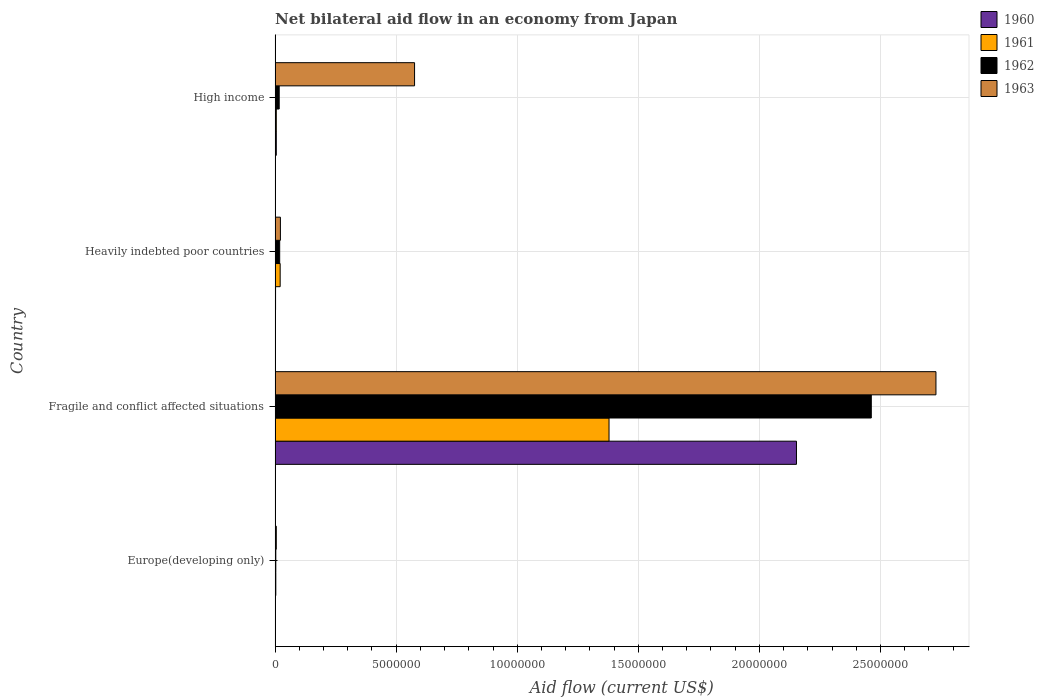How many groups of bars are there?
Keep it short and to the point. 4. Are the number of bars on each tick of the Y-axis equal?
Your answer should be compact. Yes. How many bars are there on the 4th tick from the top?
Offer a very short reply. 4. What is the label of the 3rd group of bars from the top?
Keep it short and to the point. Fragile and conflict affected situations. In how many cases, is the number of bars for a given country not equal to the number of legend labels?
Give a very brief answer. 0. What is the net bilateral aid flow in 1962 in Heavily indebted poor countries?
Give a very brief answer. 1.90e+05. Across all countries, what is the maximum net bilateral aid flow in 1962?
Make the answer very short. 2.46e+07. In which country was the net bilateral aid flow in 1961 maximum?
Give a very brief answer. Fragile and conflict affected situations. In which country was the net bilateral aid flow in 1963 minimum?
Your answer should be compact. Europe(developing only). What is the total net bilateral aid flow in 1961 in the graph?
Keep it short and to the point. 1.41e+07. What is the average net bilateral aid flow in 1962 per country?
Your answer should be very brief. 6.25e+06. What is the difference between the net bilateral aid flow in 1963 and net bilateral aid flow in 1960 in Heavily indebted poor countries?
Give a very brief answer. 2.00e+05. What is the ratio of the net bilateral aid flow in 1961 in Heavily indebted poor countries to that in High income?
Your answer should be very brief. 4.2. What is the difference between the highest and the second highest net bilateral aid flow in 1960?
Your answer should be compact. 2.15e+07. What is the difference between the highest and the lowest net bilateral aid flow in 1963?
Keep it short and to the point. 2.72e+07. In how many countries, is the net bilateral aid flow in 1960 greater than the average net bilateral aid flow in 1960 taken over all countries?
Your response must be concise. 1. Is it the case that in every country, the sum of the net bilateral aid flow in 1962 and net bilateral aid flow in 1963 is greater than the sum of net bilateral aid flow in 1960 and net bilateral aid flow in 1961?
Make the answer very short. Yes. What does the 2nd bar from the bottom in Europe(developing only) represents?
Your answer should be compact. 1961. Are all the bars in the graph horizontal?
Ensure brevity in your answer.  Yes. What is the difference between two consecutive major ticks on the X-axis?
Make the answer very short. 5.00e+06. Are the values on the major ticks of X-axis written in scientific E-notation?
Your answer should be compact. No. Does the graph contain grids?
Keep it short and to the point. Yes. How many legend labels are there?
Give a very brief answer. 4. What is the title of the graph?
Make the answer very short. Net bilateral aid flow in an economy from Japan. What is the Aid flow (current US$) of 1963 in Europe(developing only)?
Give a very brief answer. 5.00e+04. What is the Aid flow (current US$) in 1960 in Fragile and conflict affected situations?
Offer a terse response. 2.15e+07. What is the Aid flow (current US$) in 1961 in Fragile and conflict affected situations?
Offer a very short reply. 1.38e+07. What is the Aid flow (current US$) in 1962 in Fragile and conflict affected situations?
Make the answer very short. 2.46e+07. What is the Aid flow (current US$) of 1963 in Fragile and conflict affected situations?
Provide a succinct answer. 2.73e+07. What is the Aid flow (current US$) of 1961 in Heavily indebted poor countries?
Make the answer very short. 2.10e+05. What is the Aid flow (current US$) of 1961 in High income?
Provide a short and direct response. 5.00e+04. What is the Aid flow (current US$) in 1963 in High income?
Keep it short and to the point. 5.76e+06. Across all countries, what is the maximum Aid flow (current US$) in 1960?
Give a very brief answer. 2.15e+07. Across all countries, what is the maximum Aid flow (current US$) of 1961?
Your answer should be very brief. 1.38e+07. Across all countries, what is the maximum Aid flow (current US$) in 1962?
Provide a short and direct response. 2.46e+07. Across all countries, what is the maximum Aid flow (current US$) of 1963?
Keep it short and to the point. 2.73e+07. Across all countries, what is the minimum Aid flow (current US$) in 1961?
Provide a short and direct response. 3.00e+04. Across all countries, what is the minimum Aid flow (current US$) of 1962?
Make the answer very short. 3.00e+04. What is the total Aid flow (current US$) in 1960 in the graph?
Your answer should be very brief. 2.16e+07. What is the total Aid flow (current US$) in 1961 in the graph?
Offer a very short reply. 1.41e+07. What is the total Aid flow (current US$) in 1962 in the graph?
Ensure brevity in your answer.  2.50e+07. What is the total Aid flow (current US$) of 1963 in the graph?
Offer a very short reply. 3.33e+07. What is the difference between the Aid flow (current US$) in 1960 in Europe(developing only) and that in Fragile and conflict affected situations?
Ensure brevity in your answer.  -2.15e+07. What is the difference between the Aid flow (current US$) of 1961 in Europe(developing only) and that in Fragile and conflict affected situations?
Ensure brevity in your answer.  -1.38e+07. What is the difference between the Aid flow (current US$) in 1962 in Europe(developing only) and that in Fragile and conflict affected situations?
Your answer should be very brief. -2.46e+07. What is the difference between the Aid flow (current US$) in 1963 in Europe(developing only) and that in Fragile and conflict affected situations?
Offer a very short reply. -2.72e+07. What is the difference between the Aid flow (current US$) of 1960 in Europe(developing only) and that in Heavily indebted poor countries?
Provide a short and direct response. -10000. What is the difference between the Aid flow (current US$) in 1962 in Europe(developing only) and that in Heavily indebted poor countries?
Provide a short and direct response. -1.60e+05. What is the difference between the Aid flow (current US$) in 1960 in Europe(developing only) and that in High income?
Offer a terse response. -4.00e+04. What is the difference between the Aid flow (current US$) of 1961 in Europe(developing only) and that in High income?
Ensure brevity in your answer.  -2.00e+04. What is the difference between the Aid flow (current US$) in 1962 in Europe(developing only) and that in High income?
Keep it short and to the point. -1.40e+05. What is the difference between the Aid flow (current US$) of 1963 in Europe(developing only) and that in High income?
Provide a short and direct response. -5.71e+06. What is the difference between the Aid flow (current US$) of 1960 in Fragile and conflict affected situations and that in Heavily indebted poor countries?
Your response must be concise. 2.15e+07. What is the difference between the Aid flow (current US$) in 1961 in Fragile and conflict affected situations and that in Heavily indebted poor countries?
Offer a very short reply. 1.36e+07. What is the difference between the Aid flow (current US$) of 1962 in Fragile and conflict affected situations and that in Heavily indebted poor countries?
Offer a very short reply. 2.44e+07. What is the difference between the Aid flow (current US$) of 1963 in Fragile and conflict affected situations and that in Heavily indebted poor countries?
Offer a terse response. 2.71e+07. What is the difference between the Aid flow (current US$) in 1960 in Fragile and conflict affected situations and that in High income?
Your response must be concise. 2.15e+07. What is the difference between the Aid flow (current US$) in 1961 in Fragile and conflict affected situations and that in High income?
Provide a succinct answer. 1.37e+07. What is the difference between the Aid flow (current US$) in 1962 in Fragile and conflict affected situations and that in High income?
Keep it short and to the point. 2.44e+07. What is the difference between the Aid flow (current US$) in 1963 in Fragile and conflict affected situations and that in High income?
Offer a terse response. 2.15e+07. What is the difference between the Aid flow (current US$) of 1961 in Heavily indebted poor countries and that in High income?
Your response must be concise. 1.60e+05. What is the difference between the Aid flow (current US$) of 1963 in Heavily indebted poor countries and that in High income?
Give a very brief answer. -5.54e+06. What is the difference between the Aid flow (current US$) of 1960 in Europe(developing only) and the Aid flow (current US$) of 1961 in Fragile and conflict affected situations?
Give a very brief answer. -1.38e+07. What is the difference between the Aid flow (current US$) in 1960 in Europe(developing only) and the Aid flow (current US$) in 1962 in Fragile and conflict affected situations?
Provide a succinct answer. -2.46e+07. What is the difference between the Aid flow (current US$) in 1960 in Europe(developing only) and the Aid flow (current US$) in 1963 in Fragile and conflict affected situations?
Give a very brief answer. -2.73e+07. What is the difference between the Aid flow (current US$) of 1961 in Europe(developing only) and the Aid flow (current US$) of 1962 in Fragile and conflict affected situations?
Offer a very short reply. -2.46e+07. What is the difference between the Aid flow (current US$) in 1961 in Europe(developing only) and the Aid flow (current US$) in 1963 in Fragile and conflict affected situations?
Offer a very short reply. -2.73e+07. What is the difference between the Aid flow (current US$) in 1962 in Europe(developing only) and the Aid flow (current US$) in 1963 in Fragile and conflict affected situations?
Ensure brevity in your answer.  -2.73e+07. What is the difference between the Aid flow (current US$) of 1960 in Europe(developing only) and the Aid flow (current US$) of 1961 in Heavily indebted poor countries?
Provide a succinct answer. -2.00e+05. What is the difference between the Aid flow (current US$) of 1960 in Europe(developing only) and the Aid flow (current US$) of 1962 in Heavily indebted poor countries?
Your answer should be compact. -1.80e+05. What is the difference between the Aid flow (current US$) in 1961 in Europe(developing only) and the Aid flow (current US$) in 1962 in Heavily indebted poor countries?
Ensure brevity in your answer.  -1.60e+05. What is the difference between the Aid flow (current US$) in 1961 in Europe(developing only) and the Aid flow (current US$) in 1963 in Heavily indebted poor countries?
Keep it short and to the point. -1.90e+05. What is the difference between the Aid flow (current US$) in 1962 in Europe(developing only) and the Aid flow (current US$) in 1963 in Heavily indebted poor countries?
Your response must be concise. -1.90e+05. What is the difference between the Aid flow (current US$) in 1960 in Europe(developing only) and the Aid flow (current US$) in 1963 in High income?
Make the answer very short. -5.75e+06. What is the difference between the Aid flow (current US$) of 1961 in Europe(developing only) and the Aid flow (current US$) of 1963 in High income?
Give a very brief answer. -5.73e+06. What is the difference between the Aid flow (current US$) of 1962 in Europe(developing only) and the Aid flow (current US$) of 1963 in High income?
Offer a terse response. -5.73e+06. What is the difference between the Aid flow (current US$) of 1960 in Fragile and conflict affected situations and the Aid flow (current US$) of 1961 in Heavily indebted poor countries?
Your answer should be very brief. 2.13e+07. What is the difference between the Aid flow (current US$) of 1960 in Fragile and conflict affected situations and the Aid flow (current US$) of 1962 in Heavily indebted poor countries?
Ensure brevity in your answer.  2.13e+07. What is the difference between the Aid flow (current US$) of 1960 in Fragile and conflict affected situations and the Aid flow (current US$) of 1963 in Heavily indebted poor countries?
Make the answer very short. 2.13e+07. What is the difference between the Aid flow (current US$) of 1961 in Fragile and conflict affected situations and the Aid flow (current US$) of 1962 in Heavily indebted poor countries?
Make the answer very short. 1.36e+07. What is the difference between the Aid flow (current US$) of 1961 in Fragile and conflict affected situations and the Aid flow (current US$) of 1963 in Heavily indebted poor countries?
Provide a succinct answer. 1.36e+07. What is the difference between the Aid flow (current US$) in 1962 in Fragile and conflict affected situations and the Aid flow (current US$) in 1963 in Heavily indebted poor countries?
Offer a very short reply. 2.44e+07. What is the difference between the Aid flow (current US$) in 1960 in Fragile and conflict affected situations and the Aid flow (current US$) in 1961 in High income?
Make the answer very short. 2.15e+07. What is the difference between the Aid flow (current US$) in 1960 in Fragile and conflict affected situations and the Aid flow (current US$) in 1962 in High income?
Your answer should be very brief. 2.14e+07. What is the difference between the Aid flow (current US$) of 1960 in Fragile and conflict affected situations and the Aid flow (current US$) of 1963 in High income?
Offer a very short reply. 1.58e+07. What is the difference between the Aid flow (current US$) in 1961 in Fragile and conflict affected situations and the Aid flow (current US$) in 1962 in High income?
Ensure brevity in your answer.  1.36e+07. What is the difference between the Aid flow (current US$) of 1961 in Fragile and conflict affected situations and the Aid flow (current US$) of 1963 in High income?
Make the answer very short. 8.03e+06. What is the difference between the Aid flow (current US$) of 1962 in Fragile and conflict affected situations and the Aid flow (current US$) of 1963 in High income?
Provide a succinct answer. 1.89e+07. What is the difference between the Aid flow (current US$) of 1960 in Heavily indebted poor countries and the Aid flow (current US$) of 1961 in High income?
Your answer should be very brief. -3.00e+04. What is the difference between the Aid flow (current US$) of 1960 in Heavily indebted poor countries and the Aid flow (current US$) of 1963 in High income?
Make the answer very short. -5.74e+06. What is the difference between the Aid flow (current US$) in 1961 in Heavily indebted poor countries and the Aid flow (current US$) in 1962 in High income?
Your answer should be very brief. 4.00e+04. What is the difference between the Aid flow (current US$) of 1961 in Heavily indebted poor countries and the Aid flow (current US$) of 1963 in High income?
Your answer should be compact. -5.55e+06. What is the difference between the Aid flow (current US$) of 1962 in Heavily indebted poor countries and the Aid flow (current US$) of 1963 in High income?
Offer a terse response. -5.57e+06. What is the average Aid flow (current US$) of 1960 per country?
Keep it short and to the point. 5.40e+06. What is the average Aid flow (current US$) of 1961 per country?
Your answer should be compact. 3.52e+06. What is the average Aid flow (current US$) of 1962 per country?
Offer a very short reply. 6.25e+06. What is the average Aid flow (current US$) of 1963 per country?
Offer a very short reply. 8.33e+06. What is the difference between the Aid flow (current US$) in 1961 and Aid flow (current US$) in 1962 in Europe(developing only)?
Your response must be concise. 0. What is the difference between the Aid flow (current US$) of 1961 and Aid flow (current US$) of 1963 in Europe(developing only)?
Keep it short and to the point. -2.00e+04. What is the difference between the Aid flow (current US$) of 1960 and Aid flow (current US$) of 1961 in Fragile and conflict affected situations?
Give a very brief answer. 7.74e+06. What is the difference between the Aid flow (current US$) in 1960 and Aid flow (current US$) in 1962 in Fragile and conflict affected situations?
Ensure brevity in your answer.  -3.09e+06. What is the difference between the Aid flow (current US$) in 1960 and Aid flow (current US$) in 1963 in Fragile and conflict affected situations?
Offer a very short reply. -5.76e+06. What is the difference between the Aid flow (current US$) of 1961 and Aid flow (current US$) of 1962 in Fragile and conflict affected situations?
Your answer should be compact. -1.08e+07. What is the difference between the Aid flow (current US$) of 1961 and Aid flow (current US$) of 1963 in Fragile and conflict affected situations?
Keep it short and to the point. -1.35e+07. What is the difference between the Aid flow (current US$) of 1962 and Aid flow (current US$) of 1963 in Fragile and conflict affected situations?
Ensure brevity in your answer.  -2.67e+06. What is the difference between the Aid flow (current US$) in 1960 and Aid flow (current US$) in 1961 in Heavily indebted poor countries?
Provide a succinct answer. -1.90e+05. What is the difference between the Aid flow (current US$) of 1960 and Aid flow (current US$) of 1963 in High income?
Offer a terse response. -5.71e+06. What is the difference between the Aid flow (current US$) of 1961 and Aid flow (current US$) of 1962 in High income?
Offer a terse response. -1.20e+05. What is the difference between the Aid flow (current US$) of 1961 and Aid flow (current US$) of 1963 in High income?
Keep it short and to the point. -5.71e+06. What is the difference between the Aid flow (current US$) of 1962 and Aid flow (current US$) of 1963 in High income?
Your answer should be very brief. -5.59e+06. What is the ratio of the Aid flow (current US$) in 1961 in Europe(developing only) to that in Fragile and conflict affected situations?
Give a very brief answer. 0. What is the ratio of the Aid flow (current US$) of 1962 in Europe(developing only) to that in Fragile and conflict affected situations?
Your answer should be very brief. 0. What is the ratio of the Aid flow (current US$) of 1963 in Europe(developing only) to that in Fragile and conflict affected situations?
Offer a terse response. 0. What is the ratio of the Aid flow (current US$) of 1960 in Europe(developing only) to that in Heavily indebted poor countries?
Offer a very short reply. 0.5. What is the ratio of the Aid flow (current US$) in 1961 in Europe(developing only) to that in Heavily indebted poor countries?
Ensure brevity in your answer.  0.14. What is the ratio of the Aid flow (current US$) of 1962 in Europe(developing only) to that in Heavily indebted poor countries?
Offer a very short reply. 0.16. What is the ratio of the Aid flow (current US$) of 1963 in Europe(developing only) to that in Heavily indebted poor countries?
Your response must be concise. 0.23. What is the ratio of the Aid flow (current US$) in 1960 in Europe(developing only) to that in High income?
Provide a short and direct response. 0.2. What is the ratio of the Aid flow (current US$) of 1961 in Europe(developing only) to that in High income?
Keep it short and to the point. 0.6. What is the ratio of the Aid flow (current US$) in 1962 in Europe(developing only) to that in High income?
Your answer should be compact. 0.18. What is the ratio of the Aid flow (current US$) in 1963 in Europe(developing only) to that in High income?
Your response must be concise. 0.01. What is the ratio of the Aid flow (current US$) in 1960 in Fragile and conflict affected situations to that in Heavily indebted poor countries?
Give a very brief answer. 1076.5. What is the ratio of the Aid flow (current US$) of 1961 in Fragile and conflict affected situations to that in Heavily indebted poor countries?
Your answer should be compact. 65.67. What is the ratio of the Aid flow (current US$) of 1962 in Fragile and conflict affected situations to that in Heavily indebted poor countries?
Your answer should be compact. 129.58. What is the ratio of the Aid flow (current US$) in 1963 in Fragile and conflict affected situations to that in Heavily indebted poor countries?
Your answer should be very brief. 124.05. What is the ratio of the Aid flow (current US$) of 1960 in Fragile and conflict affected situations to that in High income?
Offer a terse response. 430.6. What is the ratio of the Aid flow (current US$) in 1961 in Fragile and conflict affected situations to that in High income?
Your answer should be very brief. 275.8. What is the ratio of the Aid flow (current US$) of 1962 in Fragile and conflict affected situations to that in High income?
Your answer should be compact. 144.82. What is the ratio of the Aid flow (current US$) in 1963 in Fragile and conflict affected situations to that in High income?
Offer a very short reply. 4.74. What is the ratio of the Aid flow (current US$) of 1960 in Heavily indebted poor countries to that in High income?
Provide a succinct answer. 0.4. What is the ratio of the Aid flow (current US$) in 1962 in Heavily indebted poor countries to that in High income?
Your response must be concise. 1.12. What is the ratio of the Aid flow (current US$) of 1963 in Heavily indebted poor countries to that in High income?
Ensure brevity in your answer.  0.04. What is the difference between the highest and the second highest Aid flow (current US$) in 1960?
Provide a short and direct response. 2.15e+07. What is the difference between the highest and the second highest Aid flow (current US$) in 1961?
Your answer should be compact. 1.36e+07. What is the difference between the highest and the second highest Aid flow (current US$) of 1962?
Ensure brevity in your answer.  2.44e+07. What is the difference between the highest and the second highest Aid flow (current US$) of 1963?
Provide a succinct answer. 2.15e+07. What is the difference between the highest and the lowest Aid flow (current US$) in 1960?
Provide a short and direct response. 2.15e+07. What is the difference between the highest and the lowest Aid flow (current US$) of 1961?
Your response must be concise. 1.38e+07. What is the difference between the highest and the lowest Aid flow (current US$) in 1962?
Your answer should be very brief. 2.46e+07. What is the difference between the highest and the lowest Aid flow (current US$) of 1963?
Make the answer very short. 2.72e+07. 